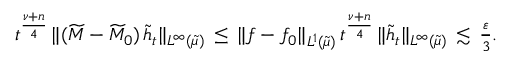Convert formula to latex. <formula><loc_0><loc_0><loc_500><loc_500>\begin{array} { r } { t ^ { \frac { \nu + n } { 4 } } \, \| ( \widetilde { M } - \widetilde { M } _ { 0 } ) \, \widetilde { h } _ { t } \| _ { L ^ { \infty } ( \widetilde { \mu } ) } \, \leq \, \| f - f _ { 0 } \| _ { L ^ { 1 } ( \widetilde { \mu } ) } \, t ^ { \frac { \nu + n } { 4 } } \, \| \widetilde { h } _ { t } \| _ { L ^ { \infty } ( \widetilde { \mu } ) } \, \lesssim \, \frac { \varepsilon } { 3 } . } \end{array}</formula> 